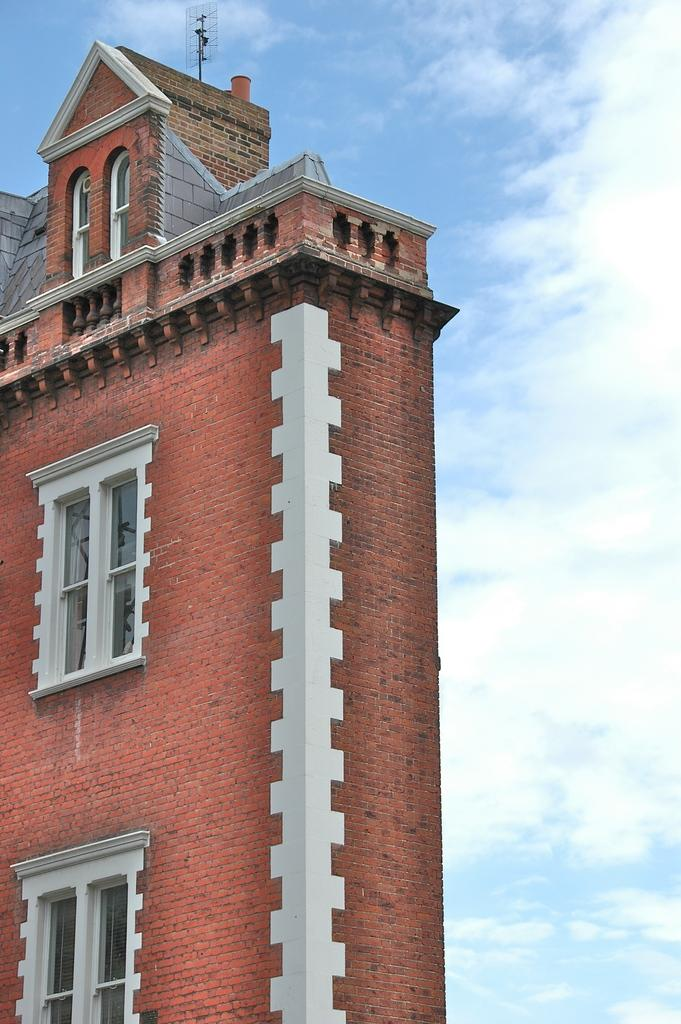What is the main structure in the image? There is a building in the image. What features can be observed on the building? The building has windows and a brown color brick wall. What can be seen in the background of the image? There are clouds and the sky visible in the background of the image. How far away is the milk carton from the building in the image? There is no milk carton present in the image, so it cannot be determined how far away it might be from the building. 